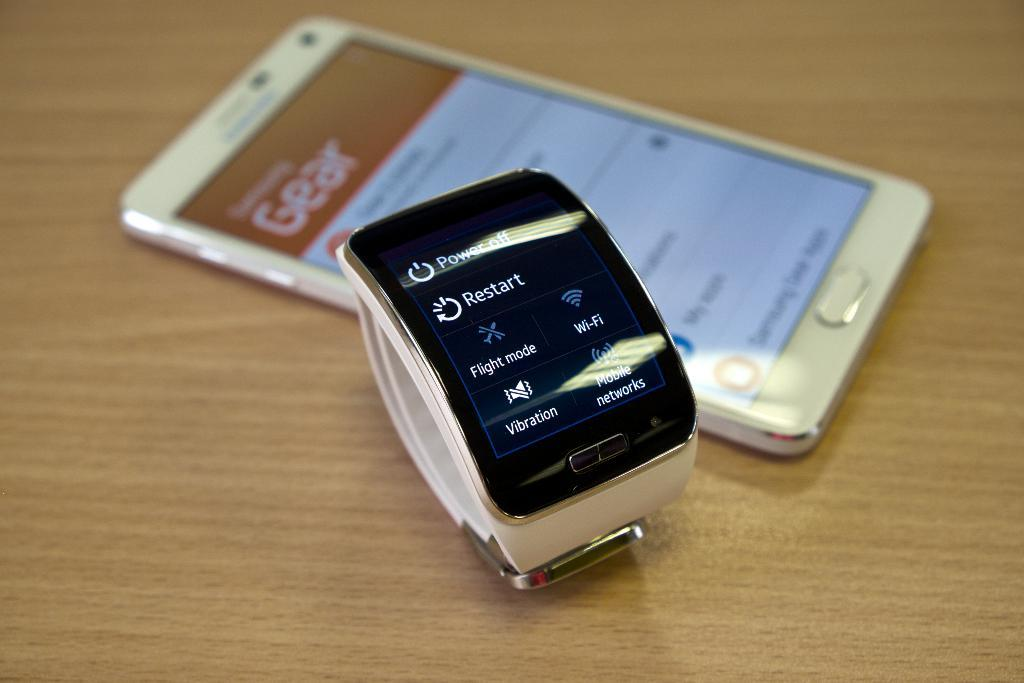<image>
Relay a brief, clear account of the picture shown. A white cellphone and smart watch are laying on a table the watch displays icons like wifi and flight mode. 